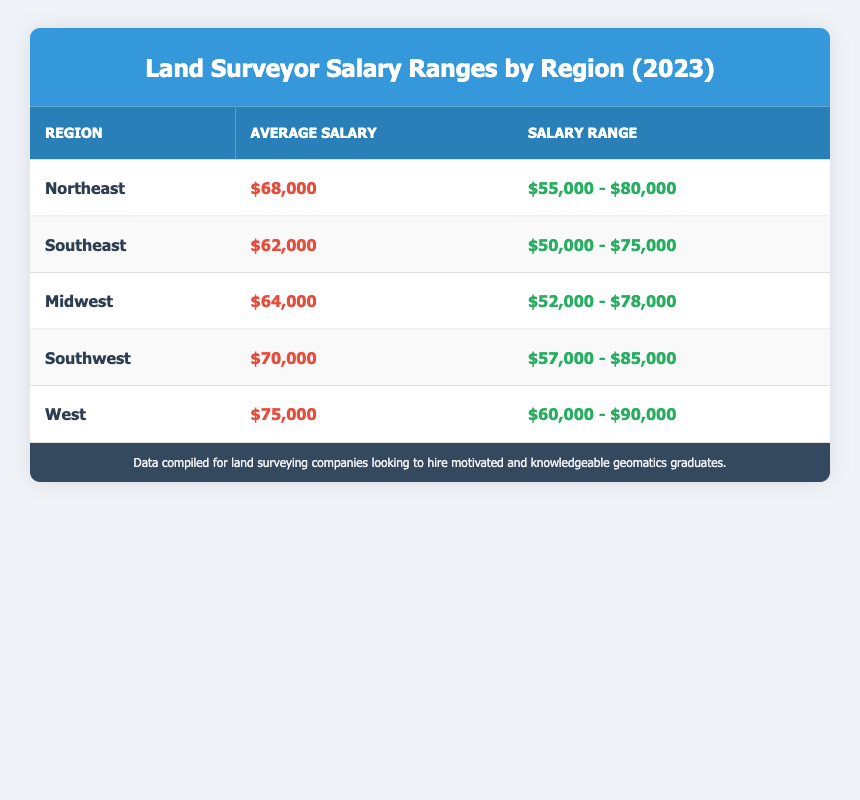What is the average salary for land surveyors in the Northeast region? The average salary listed for the Northeast region in the table is $68,000.
Answer: $68,000 Which region has the lowest average salary for land surveyors? The Southeast region, with an average salary of $62,000, has the lowest average salary compared to others in the table.
Answer: Southeast What is the salary range for land surveyors in the West region? The salary range for the West region is given as $60,000 to $90,000 according to the table.
Answer: $60,000 - $90,000 If you compare the average salaries of the Southwest and Midwest regions, which one is higher? The average salary for the Southwest region is $70,000, while the Midwest region has an average salary of $64,000. Since $70,000 is greater than $64,000, the Southwest region has a higher average salary.
Answer: Southwest Is the average salary for land surveyors in the Southeast greater than $60,000? The average salary for the Southeast region is $62,000, which is greater than $60,000.
Answer: Yes What is the difference in average salary between the Northeast and Southwest regions? The average salary in the Northeast is $68,000, and in the Southwest, it is $70,000. To find the difference, subtract the Northeast average from the Southwest average: $70,000 - $68,000 = $2,000.
Answer: $2,000 What is the maximum salary range for land surveyors in the Midwest region? The maximum salary in the Midwest region is $78,000 as outlined in the salary range data from the table.
Answer: $78,000 If a land surveyor's salary is $75,000, in which regions do they fall within the average salary range? Comparing $75,000 with the ranges provided: Northeast ($55,000 - $80,000), Southeast ($50,000 - $75,000), Midwest ($52,000 - $78,000), Southwest ($57,000 - $85,000), and West ($60,000 - $90,000) shows that $75,000 falls within the ranges for Northeast, Midwest, Southwest, and West regions.
Answer: Northeast, Midwest, Southwest, West What is the average salary for land surveyors in the Southeast region compared to the average for the West region? The average salary in the Southeast region is $62,000 while in the West region it is $75,000. Comparing these, the West region's average is greater.
Answer: West 